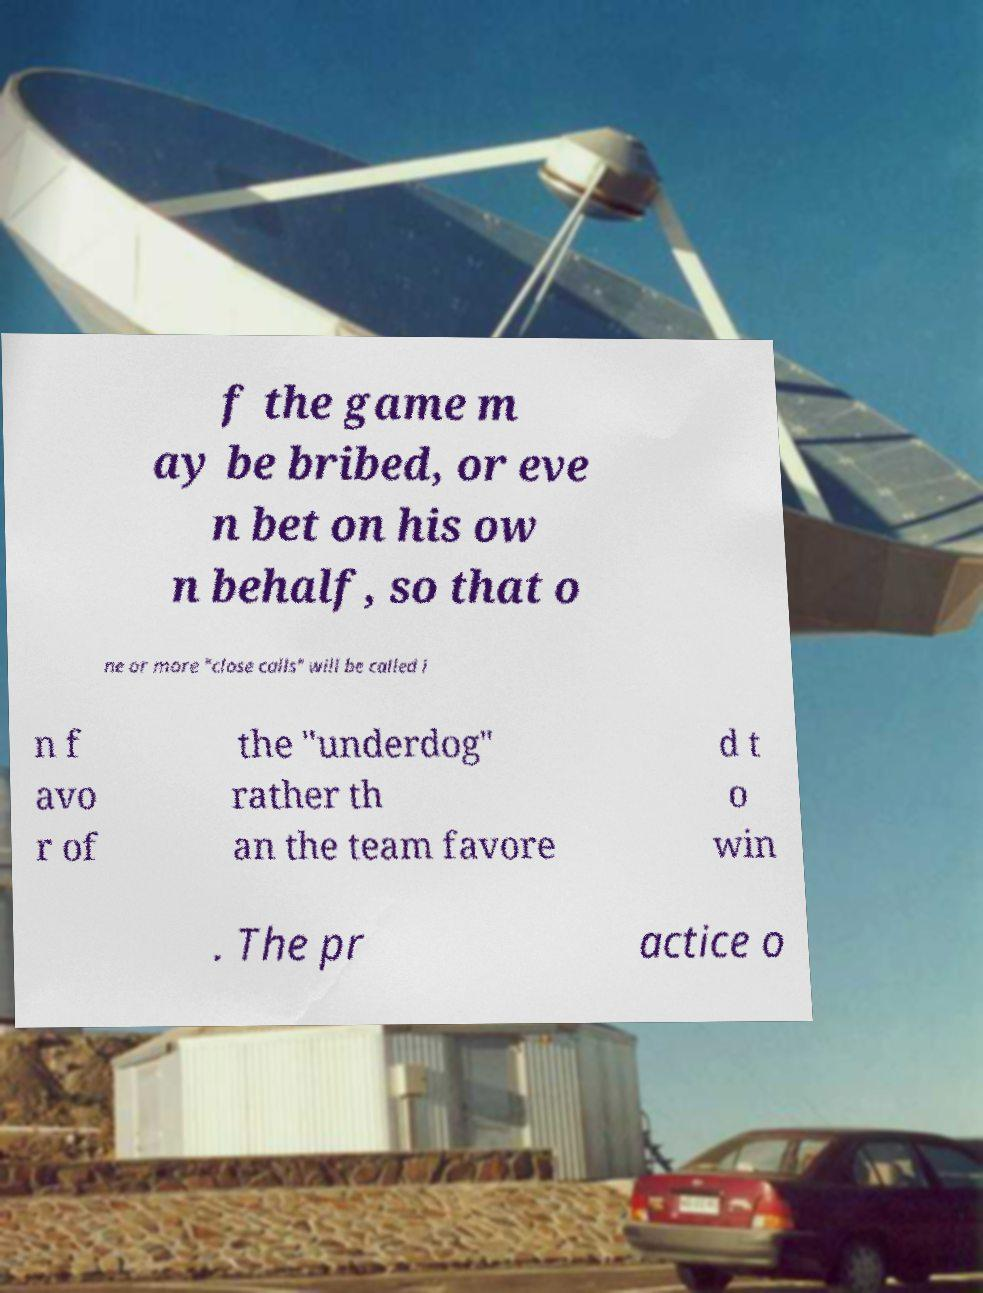Could you assist in decoding the text presented in this image and type it out clearly? f the game m ay be bribed, or eve n bet on his ow n behalf, so that o ne or more "close calls" will be called i n f avo r of the "underdog" rather th an the team favore d t o win . The pr actice o 